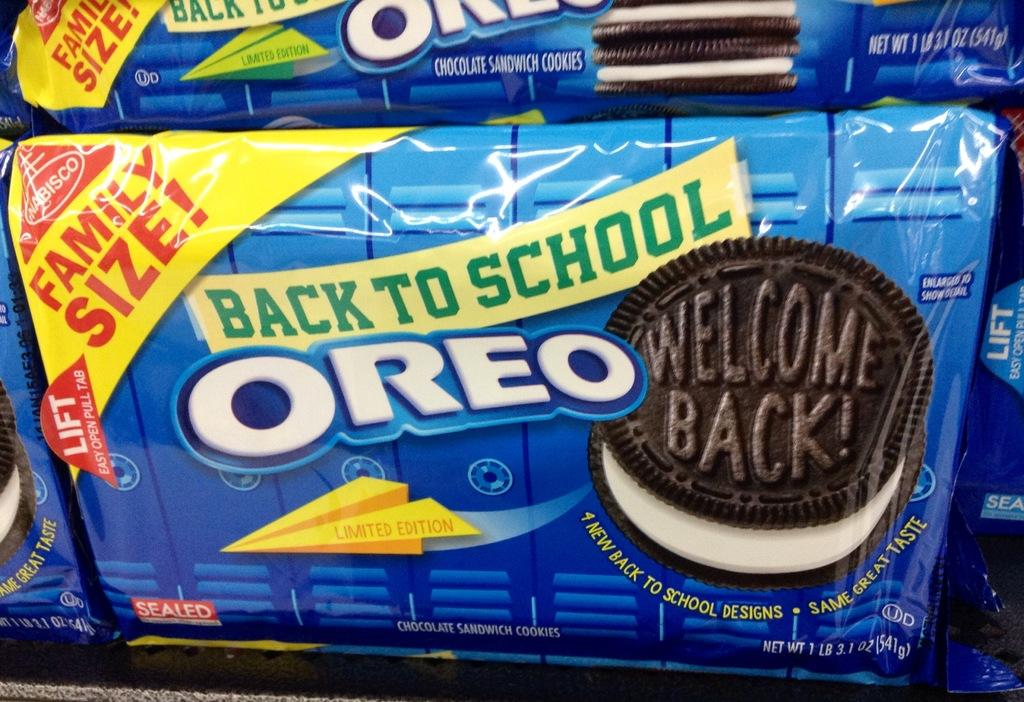Provide a one-sentence caption for the provided image. The back to school packaging for Oreo cookies. 